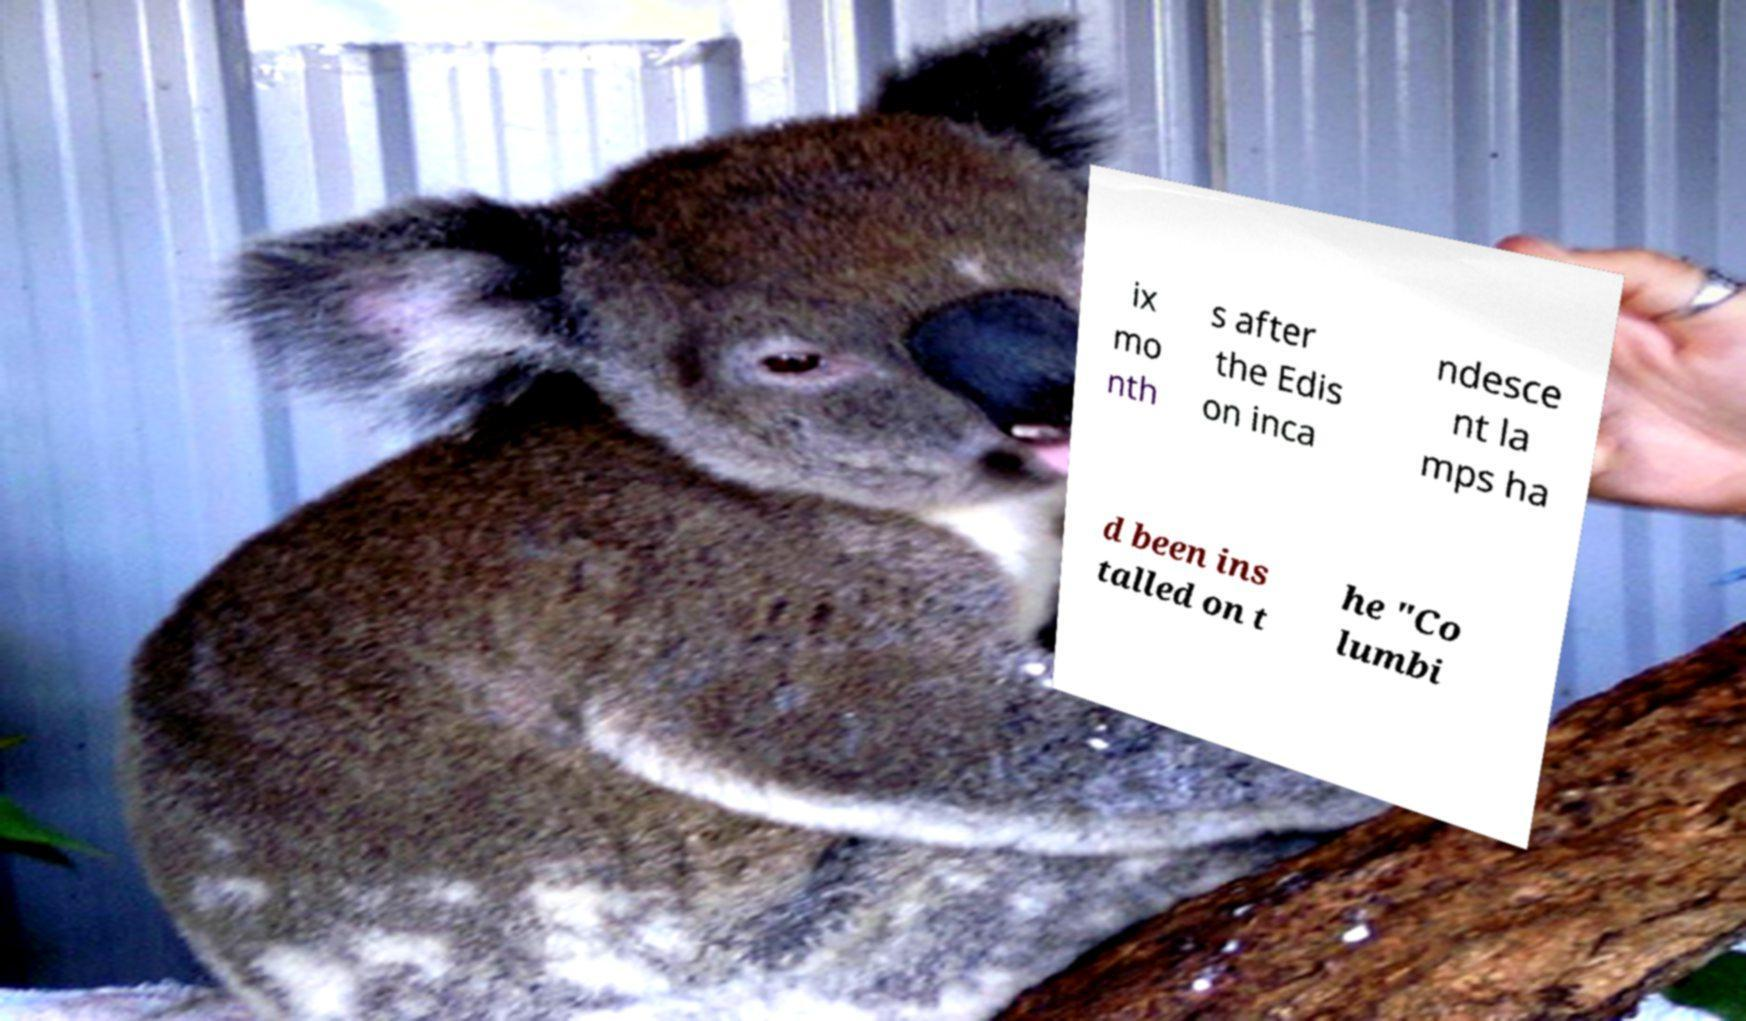Please read and relay the text visible in this image. What does it say? ix mo nth s after the Edis on inca ndesce nt la mps ha d been ins talled on t he "Co lumbi 